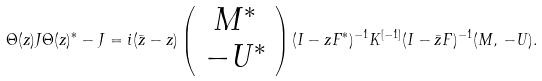<formula> <loc_0><loc_0><loc_500><loc_500>\Theta ( z ) J \Theta ( z ) ^ { * } - J = i ( \bar { z } - z ) \left ( \begin{array} { c } M ^ { * } \\ - U ^ { * } \end{array} \right ) ( I - z F ^ { * } ) ^ { - 1 } K ^ { [ - 1 ] } ( I - \bar { z } F ) ^ { - 1 } ( M , \, - U ) .</formula> 